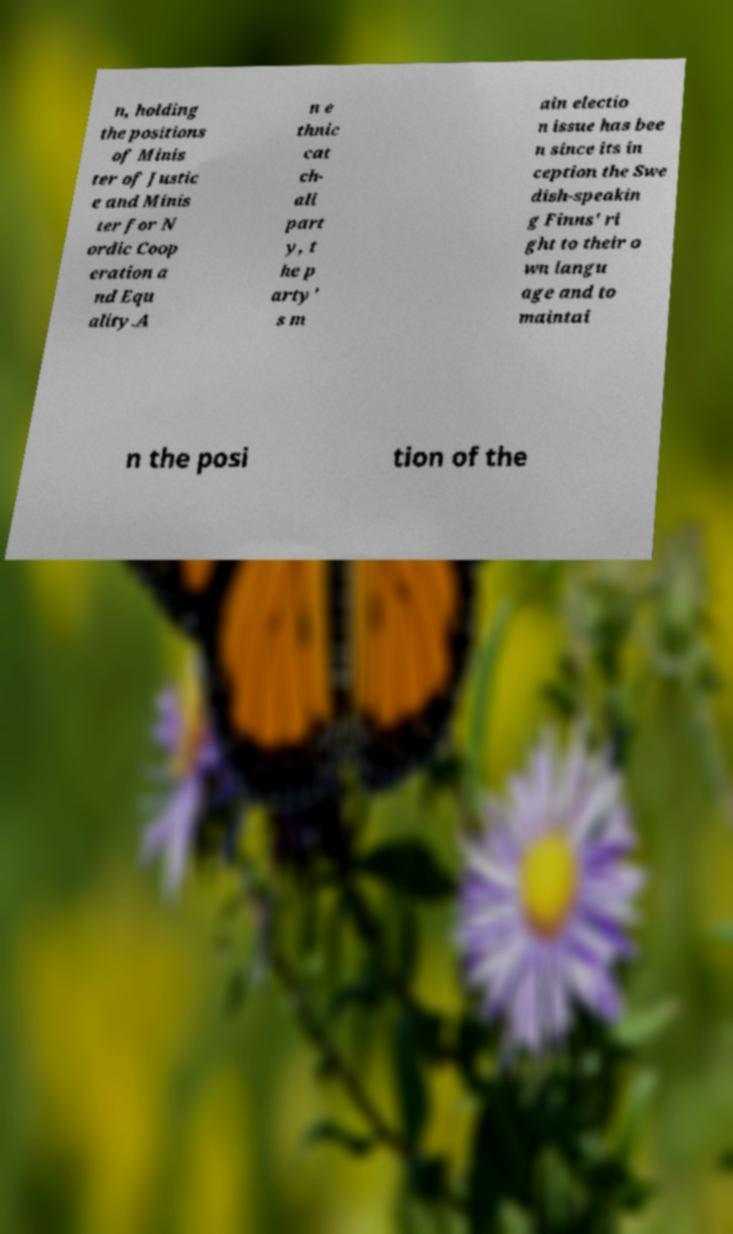Could you extract and type out the text from this image? n, holding the positions of Minis ter of Justic e and Minis ter for N ordic Coop eration a nd Equ ality.A n e thnic cat ch- all part y, t he p arty' s m ain electio n issue has bee n since its in ception the Swe dish-speakin g Finns' ri ght to their o wn langu age and to maintai n the posi tion of the 